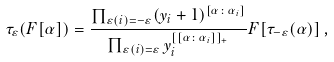<formula> <loc_0><loc_0><loc_500><loc_500>\tau _ { \varepsilon } ( F [ \alpha ] ) = \frac { \prod _ { \varepsilon ( i ) = - \varepsilon } ( y _ { i } + 1 ) ^ { [ \alpha \colon \alpha _ { i } ] } } { \prod _ { \varepsilon ( i ) = \varepsilon } y _ { i } ^ { [ [ \alpha \colon \alpha _ { i } ] ] _ { + } } } F [ \tau _ { - \varepsilon } ( \alpha ) ] \, ,</formula> 